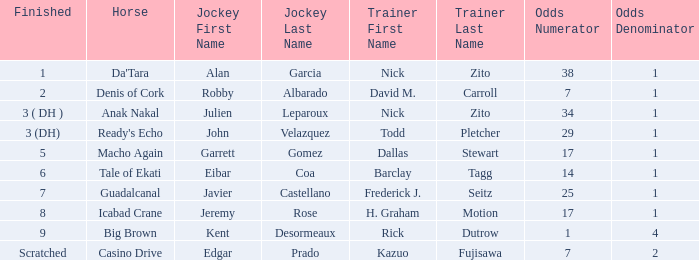Which jockey is associated with guadalcanal? Javier Castellano. 